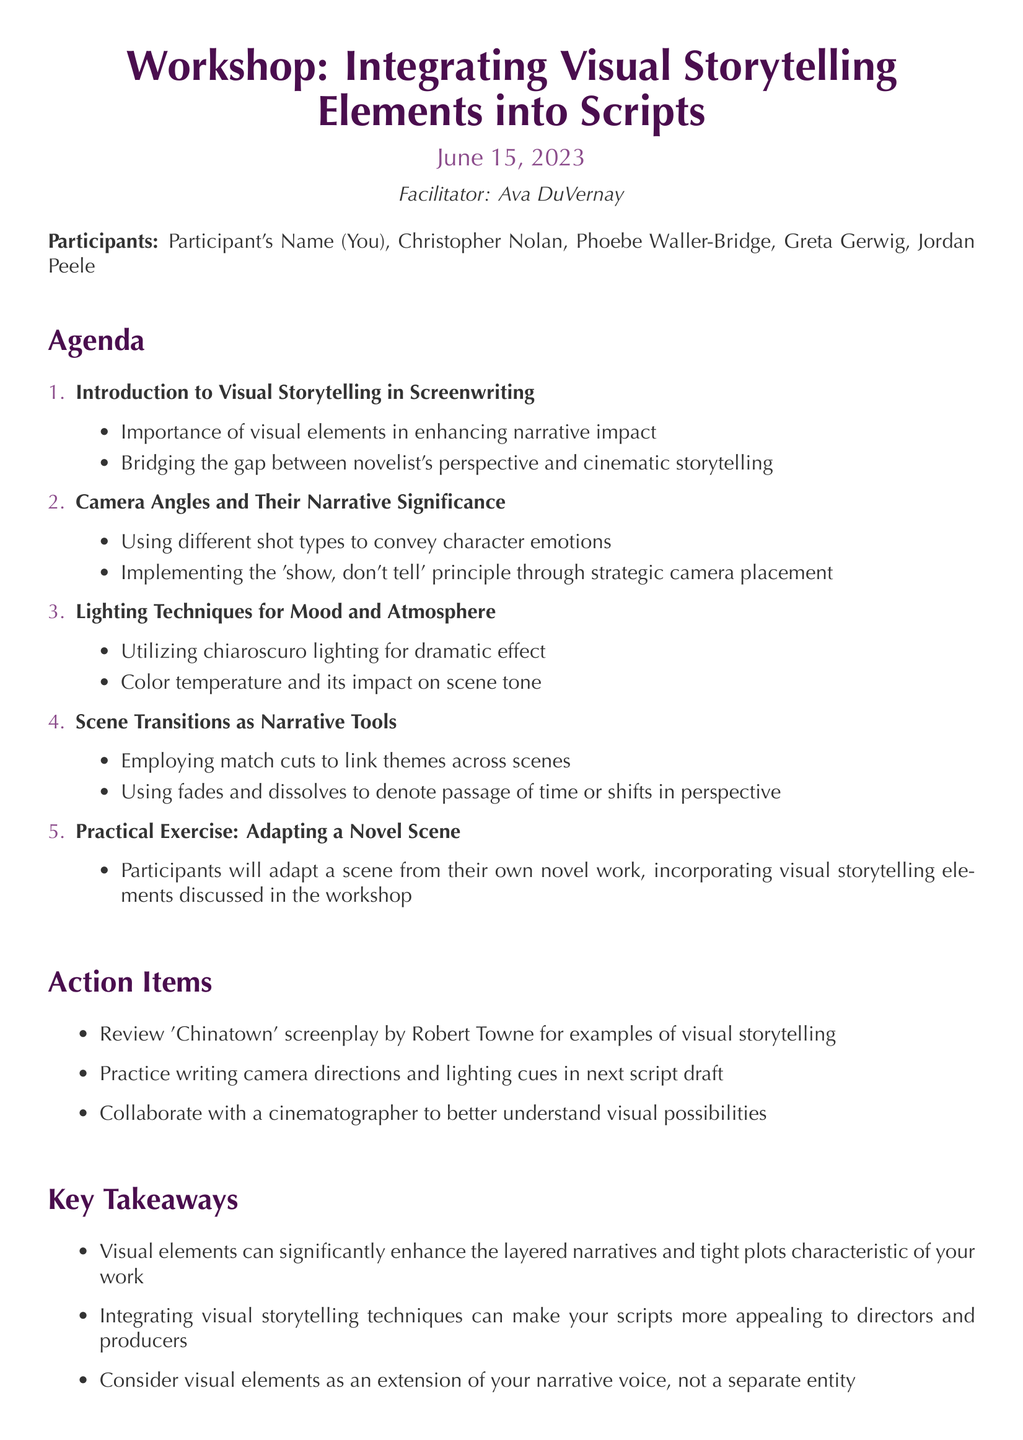What is the workshop title? The workshop title is stated at the beginning of the document.
Answer: Workshop: Integrating Visual Storytelling Elements into Scripts Who facilitated the workshop? The facilitator's name is mentioned prominently in the document.
Answer: Ava DuVernay When was the workshop held? The date of the workshop is clearly indicated in the document.
Answer: June 15, 2023 What is one of the key points discussed under camera angles? Key points are listed under each agenda item, including camera angles.
Answer: Using different shot types to convey character emotions What is one action item mentioned? Action items are provided in a specific section of the document.
Answer: Review 'Chinatown' screenplay by Robert Towne for examples of visual storytelling How many participants attended the workshop? The number of participants is derived from the list of names provided in the document.
Answer: Five What is the main focus of the practical exercise? The practical exercise description provides the main activity participants will engage in.
Answer: Adapting a scene from their own novel work What does integrating visual storytelling techniques do for scripts? The key takeaways section summarizes the benefits of visual storytelling techniques.
Answer: Make your scripts more appealing to directors and producers What lighting technique is utilized for dramatic effect? Specific techniques are mentioned under the lighting section of the agenda.
Answer: Chiaroscuro lighting 